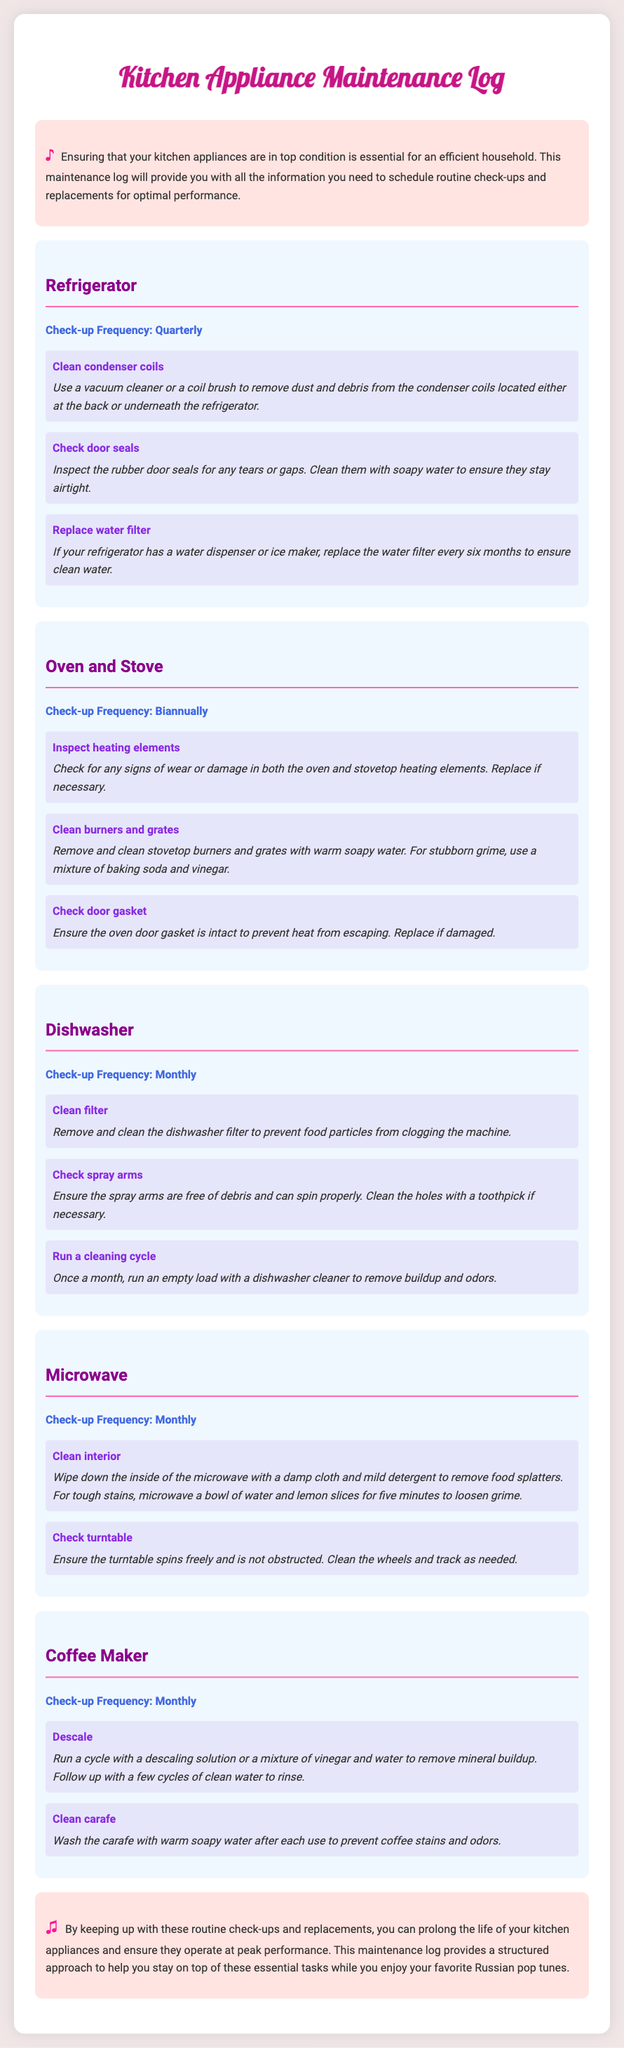What is the check-up frequency for the Dishwasher? The check-up frequency for the Dishwasher is provided in the document under the respective section, which states it is Monthly.
Answer: Monthly How often should the Refrigerator's water filter be replaced? The document specifies that the water filter for the Refrigerator should be replaced every six months, which is a part of the maintenance tasks listed.
Answer: Every six months What task is recommended for the Oven and Stove every biannually? The document mentions several tasks for the Oven and Stove which includes inspecting heating elements as one of the primary tasks recommended at that frequency.
Answer: Inspect heating elements Which appliance requires a cleaning cycle to be run once a month? The document lists the Dishwasher as requiring a cleaning cycle to be run monthly to maintain optimal performance.
Answer: Dishwasher What should be done with the Coffee Maker's carafe after each use? The document specifies that the carafe should be washed with warm soapy water after each use to prevent coffee stains and odors.
Answer: Wash with warm soapy water What visual symbol accompanies the introduction and conclusion sections? The document includes musical notes as symbols in both the introduction and the conclusion sections, highlighting an element related to music.
Answer: Musical notes What is the primary purpose of the Kitchen Appliance Maintenance Log? The document outlines that the main purpose is to provide information for scheduling routine check-ups and replacements for kitchen appliances.
Answer: Provide information for scheduling maintenance How many tasks are listed for the Microwave appliance? The document states there are two tasks listed for the Microwave's maintenance under its section.
Answer: Two tasks 